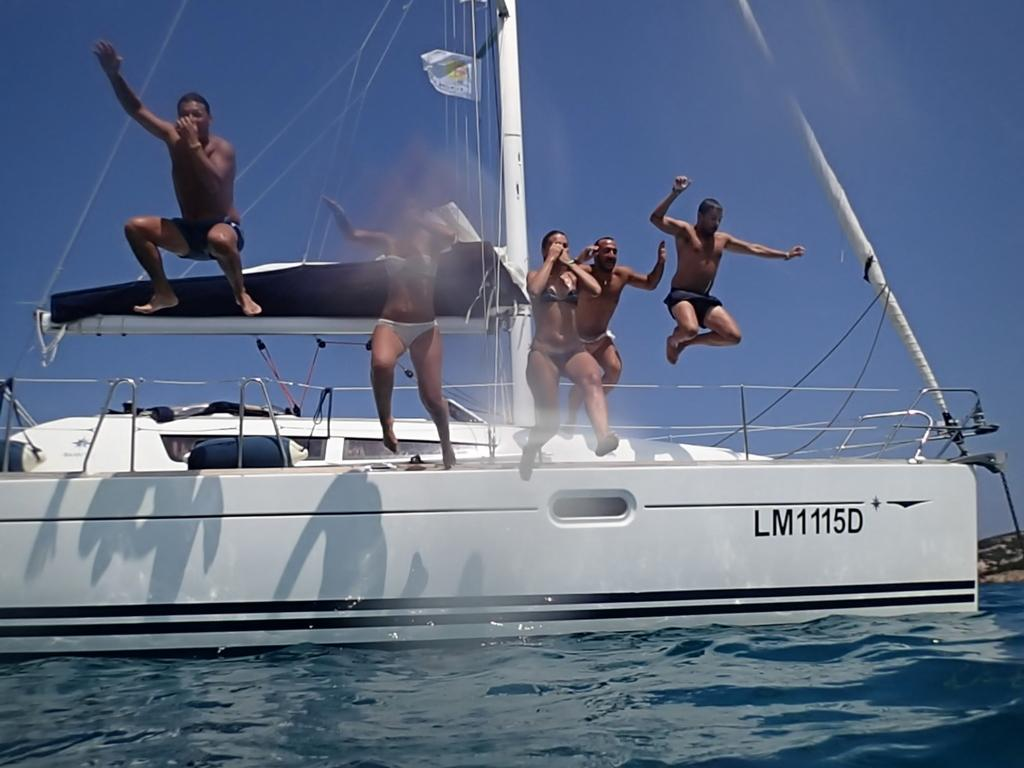What is happening in the image involving a group of people? The people are jumping from a ship in the image. What is the ship's condition in the image? The ship is floating on water in the image. Is there any text visible on the ship? Yes, there is text on the ship in the image. What type of wrench is being used by the man in the image? There is no man or wrench present in the image; it features a group of people jumping from a ship. Are the people in the image sleeping or resting? No, the people in the image are jumping from the ship, not sleeping or resting. 